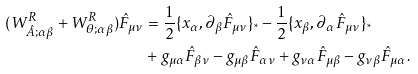<formula> <loc_0><loc_0><loc_500><loc_500>( W ^ { R } _ { \hat { A } ; \alpha \beta } + W ^ { R } _ { \theta ; \alpha \beta } ) \hat { F } _ { \mu \nu } & = \frac { 1 } { 2 } \{ x _ { \alpha } , \partial _ { \beta } \hat { F } _ { \mu \nu } \} _ { ^ { * } } - \frac { 1 } { 2 } \{ x _ { \beta } , \partial _ { \alpha } \hat { F } _ { \mu \nu } \} _ { ^ { * } } \\ & + g _ { \mu \alpha } \hat { F } _ { \beta \nu } - g _ { \mu \beta } \hat { F } _ { \alpha \nu } + g _ { \nu \alpha } \hat { F } _ { \mu \beta } - g _ { \nu \beta } \hat { F } _ { \mu \alpha } .</formula> 